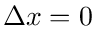<formula> <loc_0><loc_0><loc_500><loc_500>\Delta x = 0</formula> 